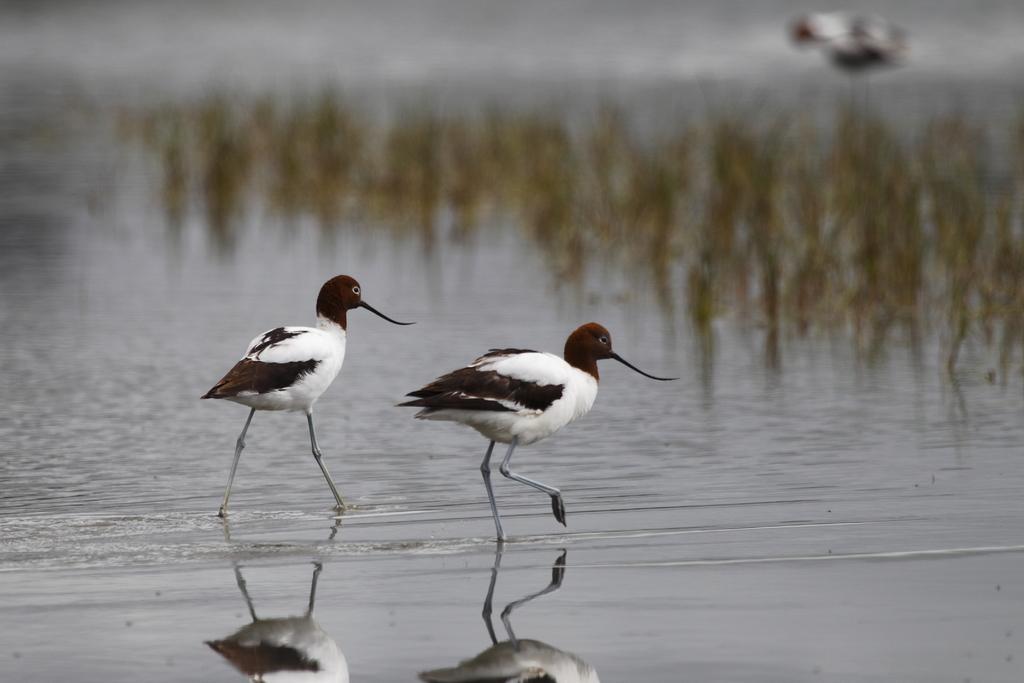How would you summarize this image in a sentence or two? In the image I can see two birds which are in the water and also I can see some plants to the side. 